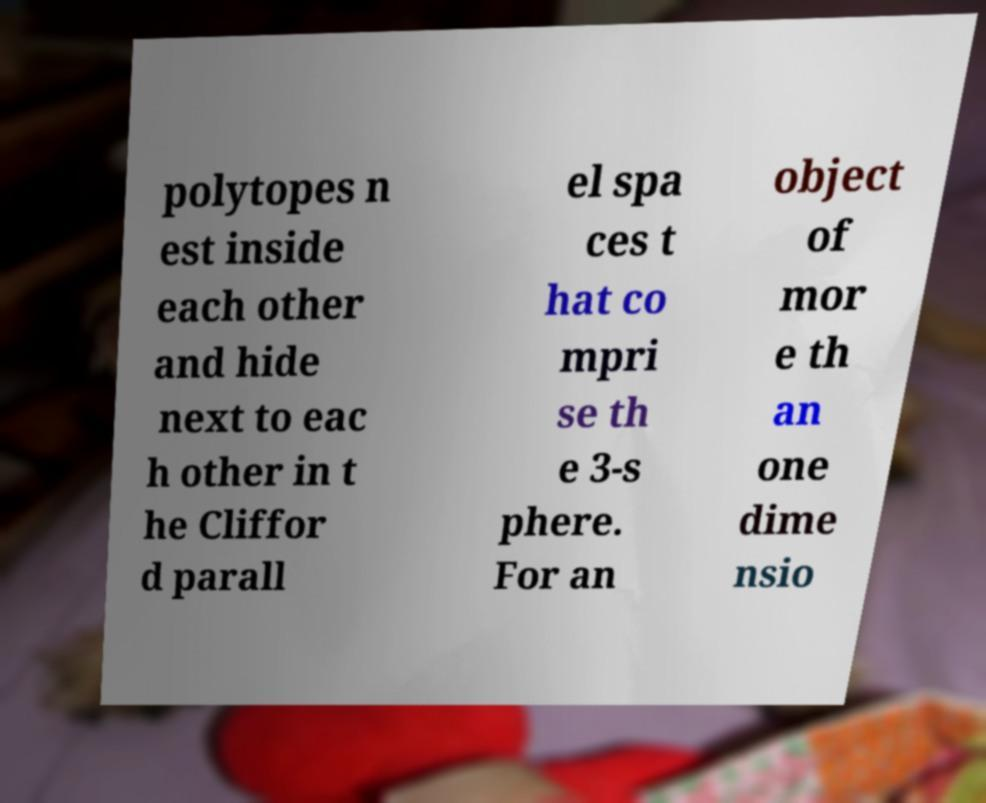Could you extract and type out the text from this image? polytopes n est inside each other and hide next to eac h other in t he Cliffor d parall el spa ces t hat co mpri se th e 3-s phere. For an object of mor e th an one dime nsio 